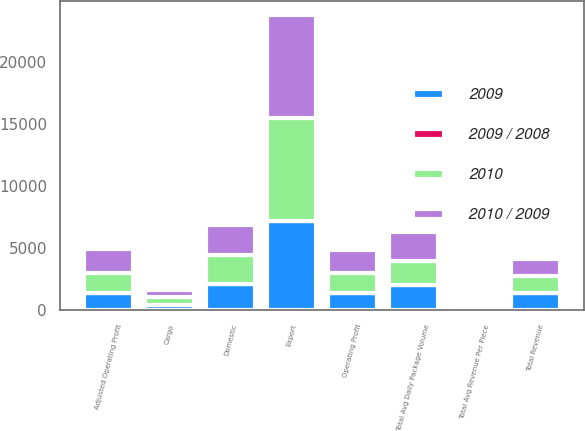Convert chart. <chart><loc_0><loc_0><loc_500><loc_500><stacked_bar_chart><ecel><fcel>Domestic<fcel>Export<fcel>Cargo<fcel>Total Revenue<fcel>Total Avg Daily Package Volume<fcel>Total Avg Revenue Per Piece<fcel>Operating Profit<fcel>Adjusted Operating Profit<nl><fcel>2010 / 2009<fcel>2365<fcel>8234<fcel>534<fcel>1367<fcel>2288<fcel>18.31<fcel>1904<fcel>1904<nl><fcel>2009<fcel>2111<fcel>7176<fcel>412<fcel>1367<fcel>2014<fcel>18.23<fcel>1367<fcel>1367<nl><fcel>2010<fcel>2344<fcel>8294<fcel>655<fcel>1367<fcel>1963<fcel>21.5<fcel>1580<fcel>1607<nl><fcel>2009 / 2008<fcel>12<fcel>14.7<fcel>29.6<fcel>14.8<fcel>13.6<fcel>0.4<fcel>39.3<fcel>39.3<nl></chart> 